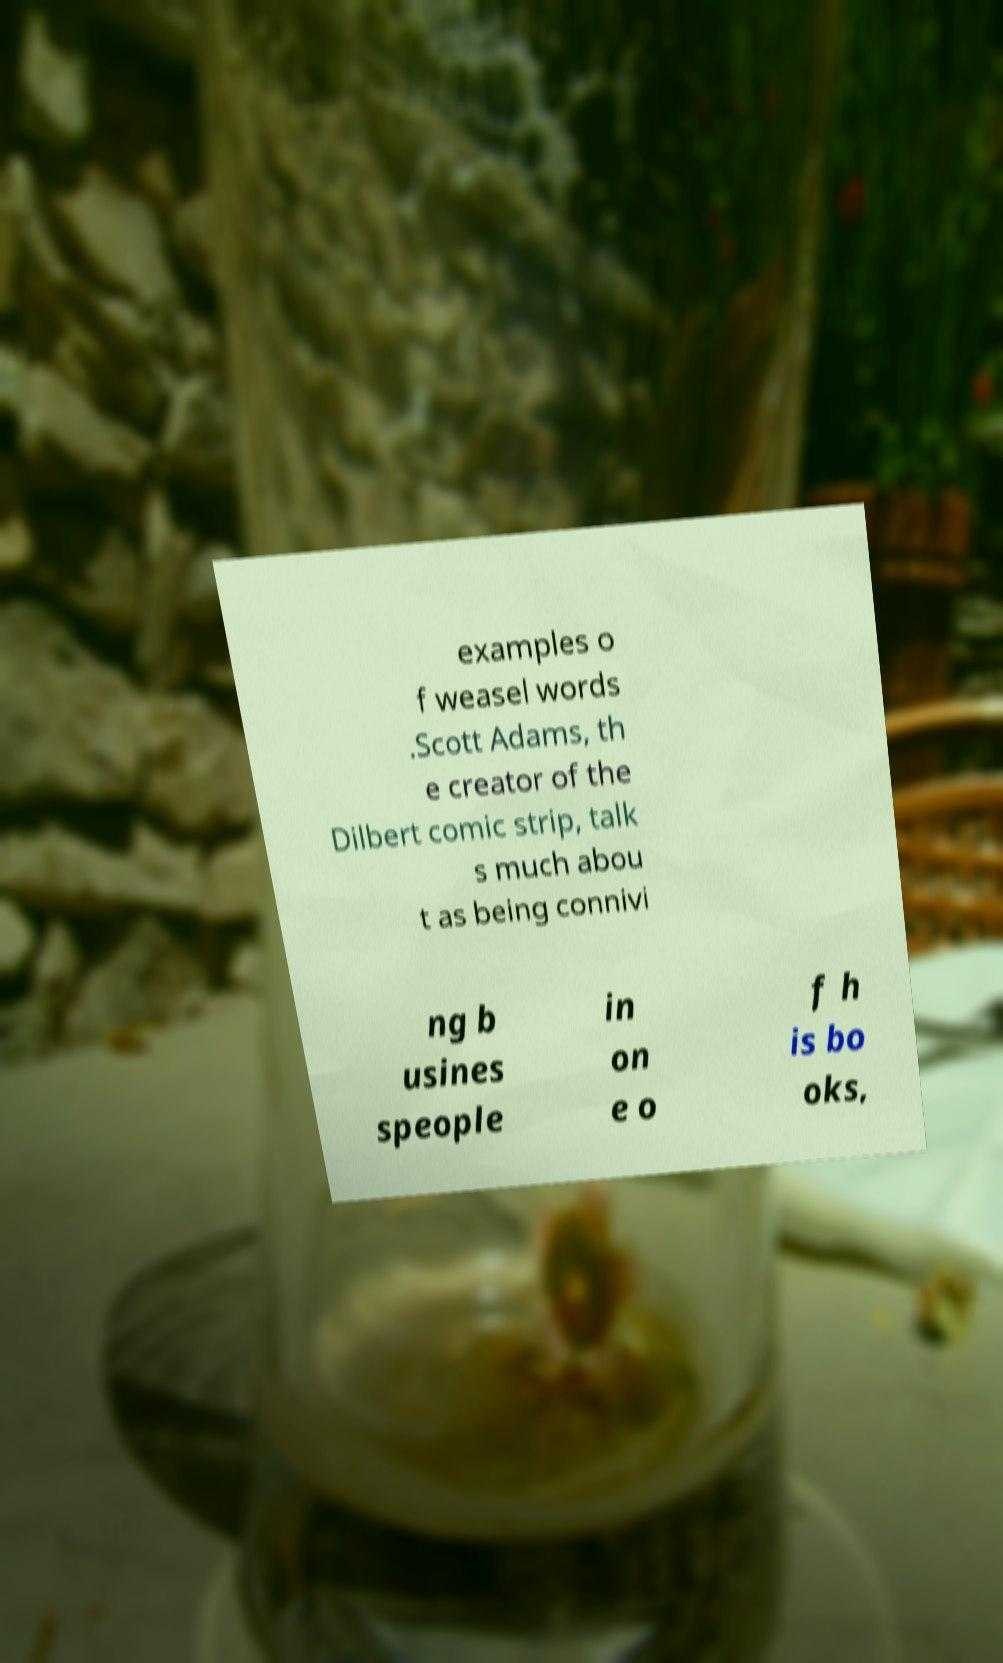I need the written content from this picture converted into text. Can you do that? examples o f weasel words .Scott Adams, th e creator of the Dilbert comic strip, talk s much abou t as being connivi ng b usines speople in on e o f h is bo oks, 